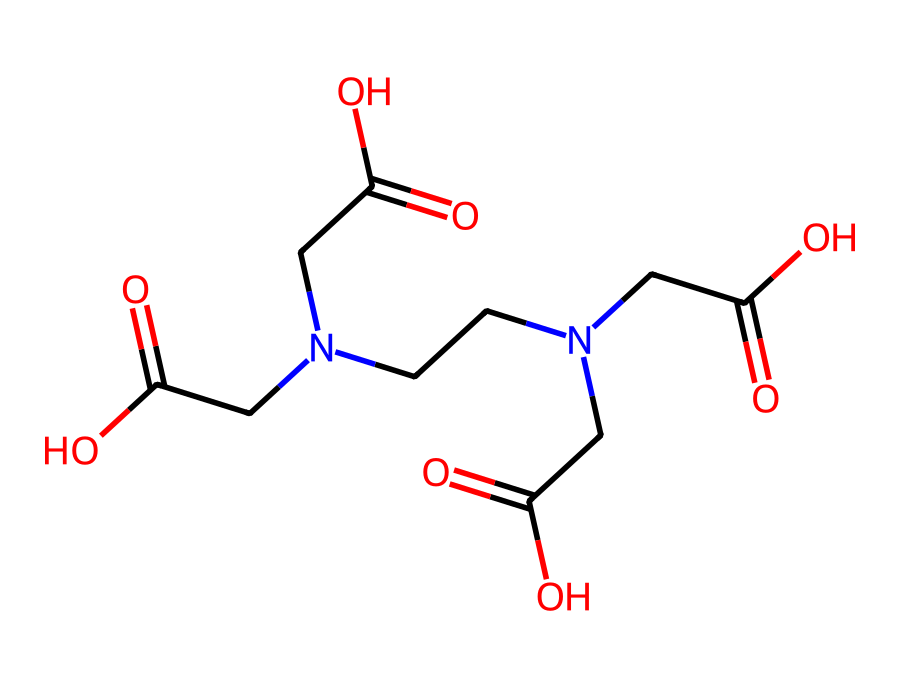How many nitrogen atoms are present in this chemical? By examining the structure represented in the SMILES notation, we identify two nitrogen atoms in the molecule. The presence of "N" indicates nitrogen.
Answer: 2 What functional groups are present in this chemical? The SMILES notation shows the presence of carboxylic acid groups (indicated by "CC(=O)O"). In the structure, we can see multiple instances of this group.
Answer: carboxylic acid What is the overall charge of the molecule? The molecule does not display additional symbols that would indicate charges (e.g., '-' or '+'), so it can be assumed to be neutral.
Answer: neutral How many oxygen atoms are in this chemical? By counting the "O" in the SMILES representation, we find that there are six oxygen atoms in total.
Answer: 6 Does this chemical likely chelate metal ions? The presence of multiple carboxylic acid functional groups suggests that the molecule has the ability to form complexes with metal ions, making it a chelating agent.
Answer: yes What type of chemical is this compound primarily used as? Given the presence of multiple functional groups that facilitate the removal of mineral deposits, this compound is primarily used as a detergent.
Answer: detergent 